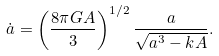Convert formula to latex. <formula><loc_0><loc_0><loc_500><loc_500>\dot { a } = \left ( \frac { 8 \pi G A } { 3 } \right ) ^ { 1 / 2 } \frac { a } { \sqrt { a ^ { 3 } - k A } } .</formula> 